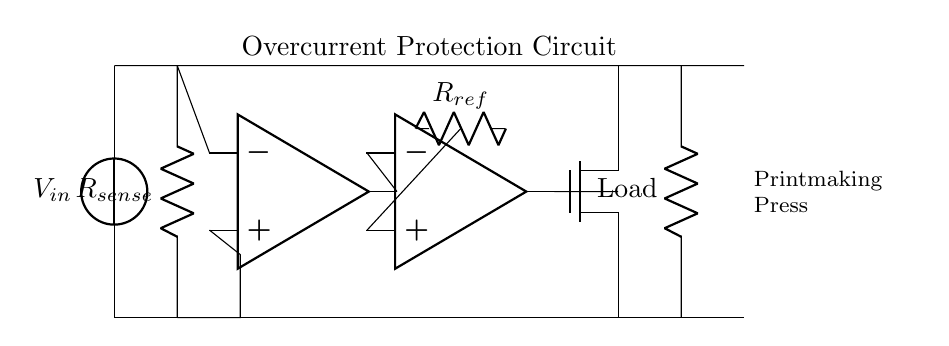What is the function of the resistor labeled R sense? The resistor labeled R sense is used to sense the current flowing through the circuit by developing a voltage drop proportional to the current.
Answer: Sensing current What type of component is located at the position of the second operational amplifier? The second operational amplifier in the circuit is functioning as a comparator, comparing the voltage from R sense with a reference voltage.
Answer: Comparator What is the role of the MOSFET in this circuit? The MOSFET acts as a switch that can cut off the flow of current to the load when the current exceeds a certain threshold as determined by the comparator.
Answer: Switch What happens when the current exceeds a predefined limit? When the current exceeds the predefined limit, the comparator outputs a signal that turns off the MOSFET, thereby disconnecting the load from the power source.
Answer: Disconnect load What is the purpose of the reference resistor labeled R ref? The reference resistor R ref sets the reference voltage for the comparator, establishing the threshold at which the overcurrent protection is activated.
Answer: Sets threshold What is the input voltage source labeled V in? The input voltage source V in supplies electrical power for the circuit and the connected load, in this case, the printmaking press.
Answer: Power supply What does the load represent in this circuit? The load in this circuit represents the printmaking press, which is the device being protected from overcurrent conditions.
Answer: Printmaking press 